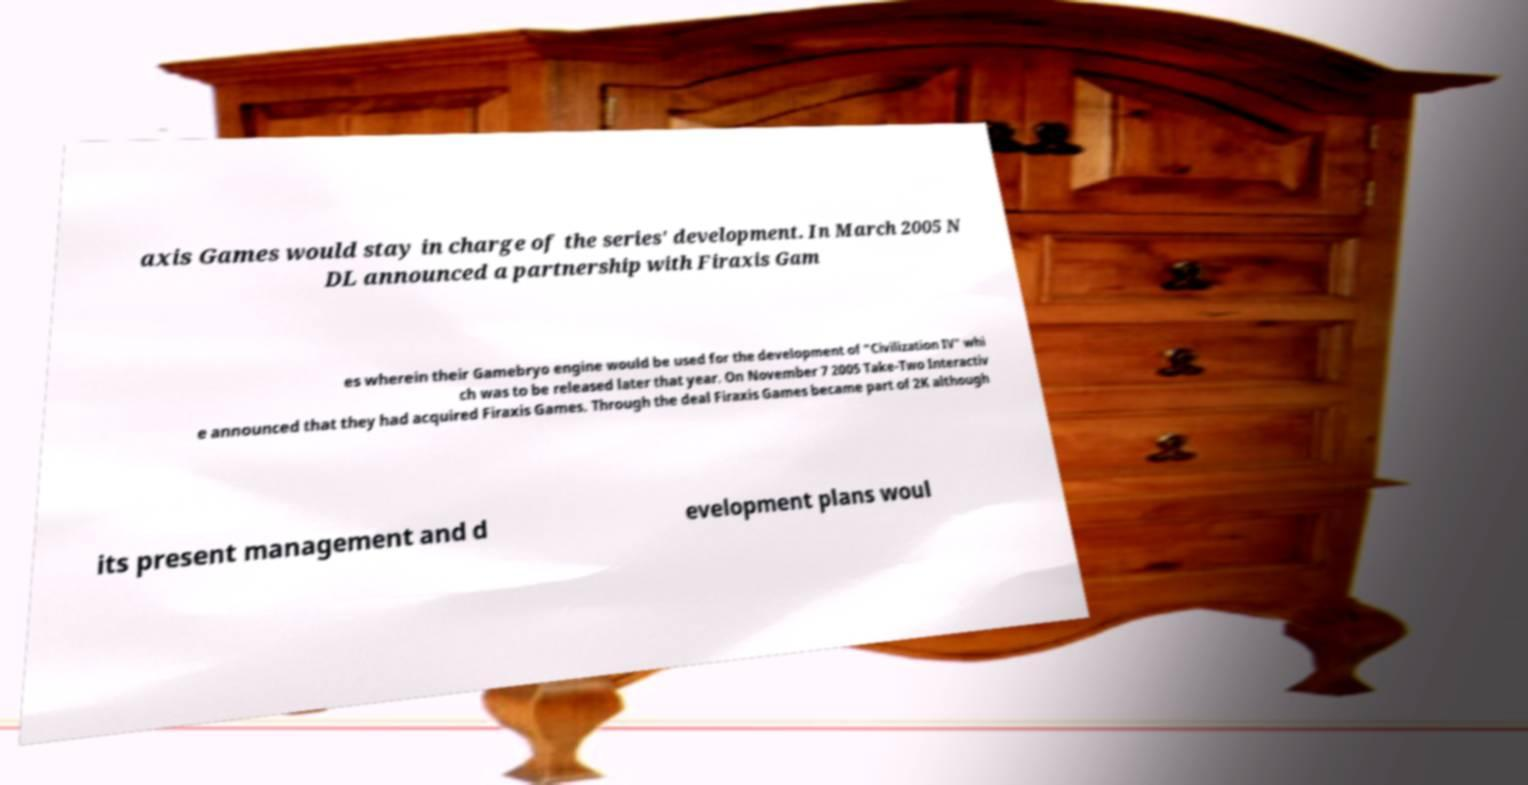I need the written content from this picture converted into text. Can you do that? axis Games would stay in charge of the series' development. In March 2005 N DL announced a partnership with Firaxis Gam es wherein their Gamebryo engine would be used for the development of "Civilization IV" whi ch was to be released later that year. On November 7 2005 Take-Two Interactiv e announced that they had acquired Firaxis Games. Through the deal Firaxis Games became part of 2K although its present management and d evelopment plans woul 